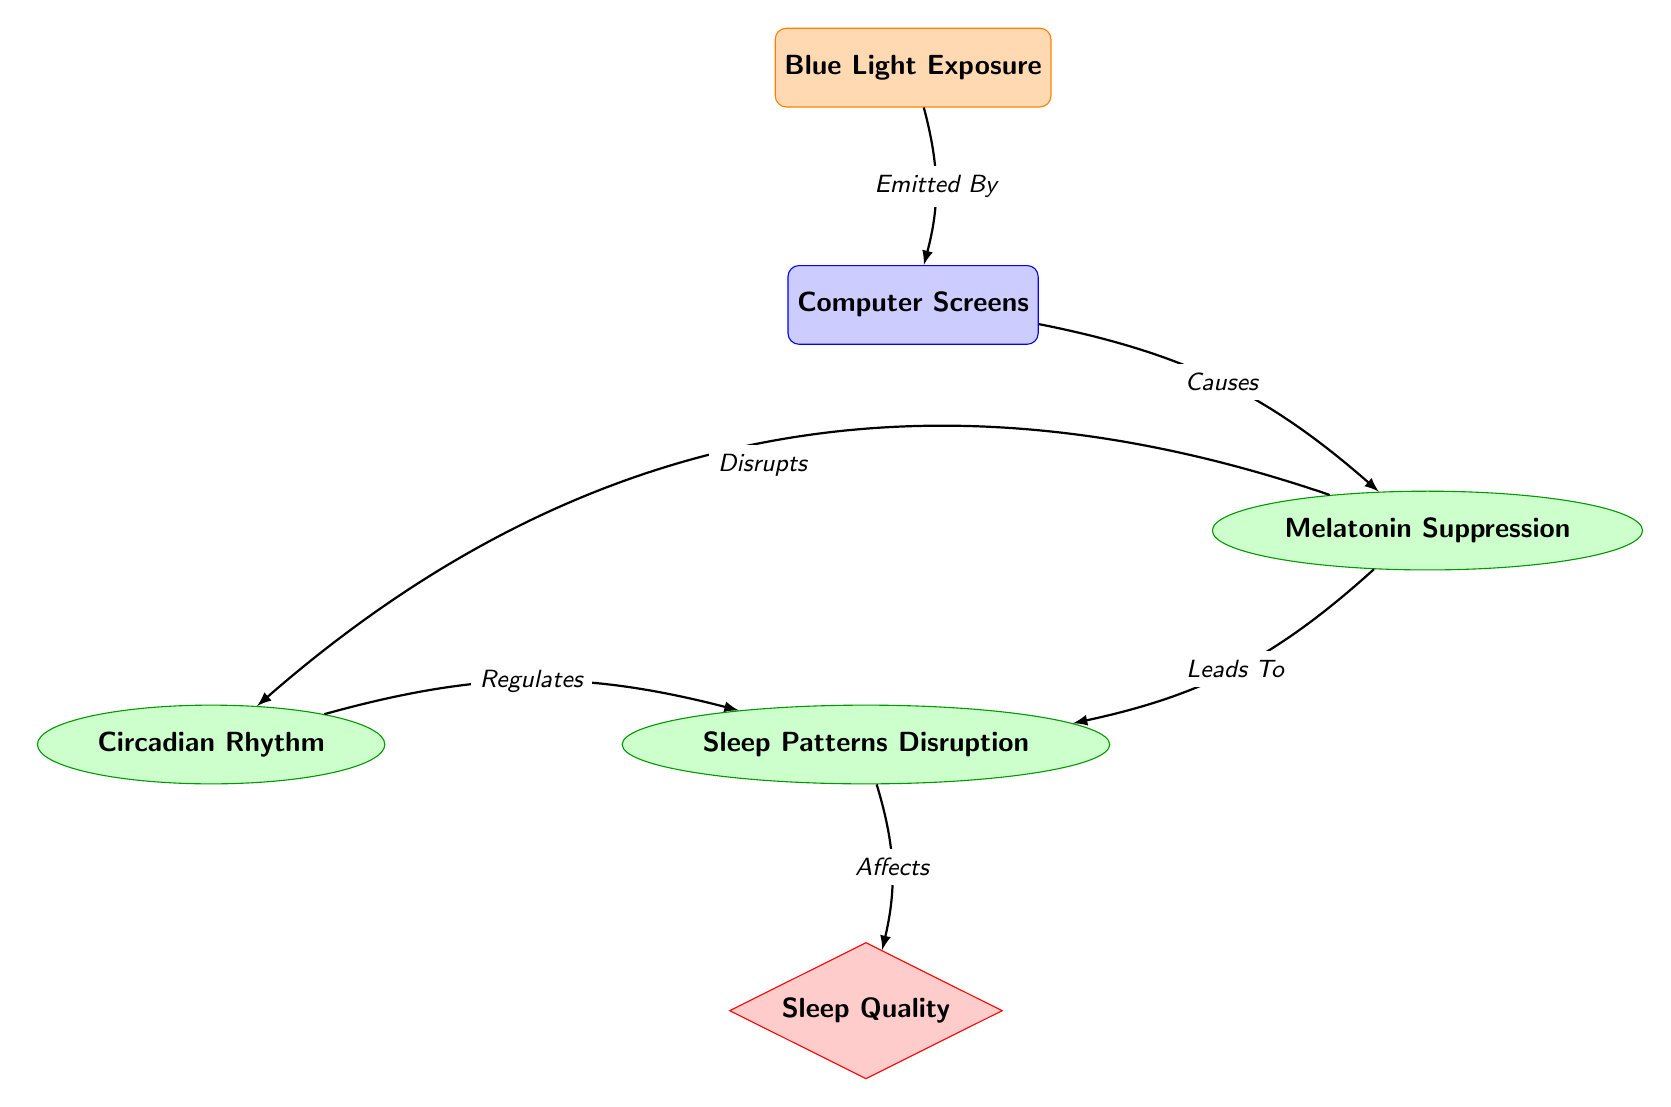What is the first node in the diagram? The first node in the diagram is labeled "Blue Light Exposure." This is determined by looking at the topmost node in the diagram.
Answer: Blue Light Exposure How many biological processes are represented in the diagram? There are three biological processes in the diagram, which are "Melatonin Suppression," "Sleep Patterns Disruption," and "Circadian Rhythm." By counting the nodes categorized as biological processes, we find a total of three.
Answer: 3 What does "Melatonin Suppression" lead to? "Melatonin Suppression" leads to "Sleep Patterns Disruption." This relationship is shown by the arrow pointing from the "Melatonin Suppression" node to the "Sleep Patterns Disruption" node.
Answer: Sleep Patterns Disruption Which node is affected by "Sleep Patterns Disruption"? "Sleep Patterns Disruption" affects "Sleep Quality." This can be observed from the diagram, where an arrow points from "Sleep Patterns Disruption" down to "Sleep Quality," indicating an effect.
Answer: Sleep Quality What regulates "Sleep Patterns Disruption"? "Circadian Rhythm" regulates "Sleep Patterns Disruption." This is indicated by the arrow directed from "Circadian Rhythm" to "Sleep Patterns Disruption."
Answer: Circadian Rhythm How does "Melatonin Suppression" disrupt the "Circadian Rhythm"? "Melatonin Suppression" disrupts "Circadian Rhythm" as shown by the bend right arrow indicating a disruptive relationship, meaning that increased melatonin suppression negatively impacts the circadian rhythm.
Answer: Disrupts What effect does "Blue Light Exposure" have on "Computer Screens"? "Blue Light Exposure" causes "Computer Screens." This is indicated by the arrow that connects these two nodes, demonstrating the cause-and-effect relationship.
Answer: Causes 